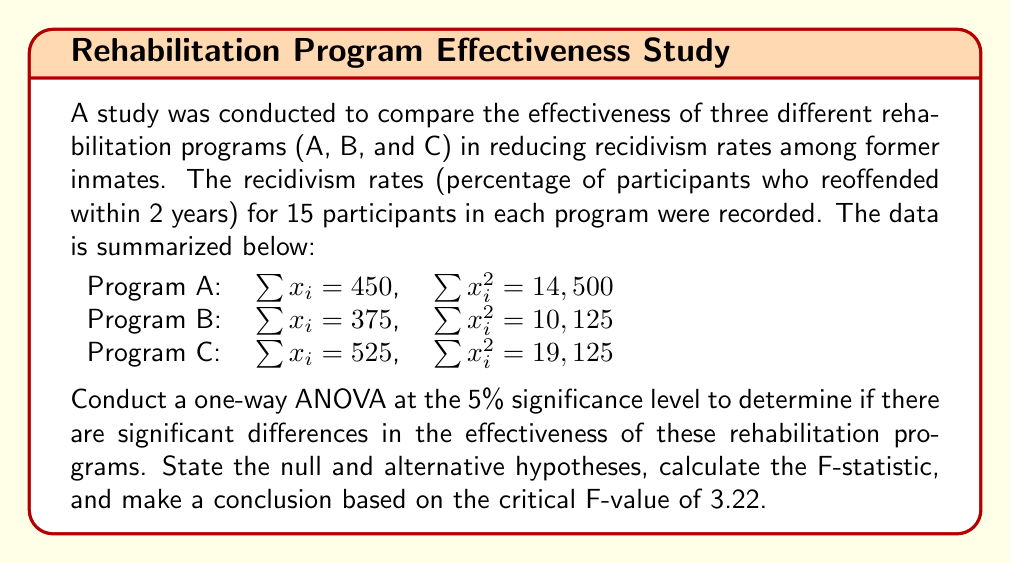What is the answer to this math problem? Let's approach this step-by-step:

1) First, we state our hypotheses:
   $H_0$: $\mu_A = \mu_B = \mu_C$ (all programs have equal effectiveness)
   $H_1$: At least one mean is different (at least one program has different effectiveness)

2) We need to calculate the following:
   - Grand mean
   - Sum of Squares Total (SST)
   - Sum of Squares Between (SSB)
   - Sum of Squares Within (SSW)
   - Degrees of freedom
   - Mean Square Between (MSB)
   - Mean Square Within (MSW)
   - F-statistic

3) Calculate the grand mean:
   $\bar{X} = \frac{450 + 375 + 525}{45} = 30$

4) Calculate SST:
   $SST = (14,500 + 10,125 + 19,125) - 45(30)^2 = 43,750 - 40,500 = 3,250$

5) Calculate SSB:
   $SSB = \frac{450^2 + 375^2 + 525^2}{15} - 45(30)^2 = 42,750 - 40,500 = 2,250$

6) Calculate SSW:
   $SSW = SST - SSB = 3,250 - 2,250 = 1,000$

7) Degrees of freedom:
   $df_{between} = k - 1 = 3 - 1 = 2$ (where k is the number of groups)
   $df_{within} = N - k = 45 - 3 = 42$ (where N is the total number of observations)

8) Calculate MSB and MSW:
   $MSB = \frac{SSB}{df_{between}} = \frac{2,250}{2} = 1,125$
   $MSW = \frac{SSW}{df_{within}} = \frac{1,000}{42} = 23.81$

9) Calculate the F-statistic:
   $F = \frac{MSB}{MSW} = \frac{1,125}{23.81} = 47.25$

10) Compare the F-statistic to the critical F-value:
    The calculated F-statistic (47.25) is greater than the critical F-value (3.22).

Therefore, we reject the null hypothesis at the 5% significance level.
Answer: Reject the null hypothesis. There is significant evidence at the 5% level to conclude that there are differences in the effectiveness of the rehabilitation programs in reducing recidivism rates (F = 47.25 > F_crit = 3.22). 